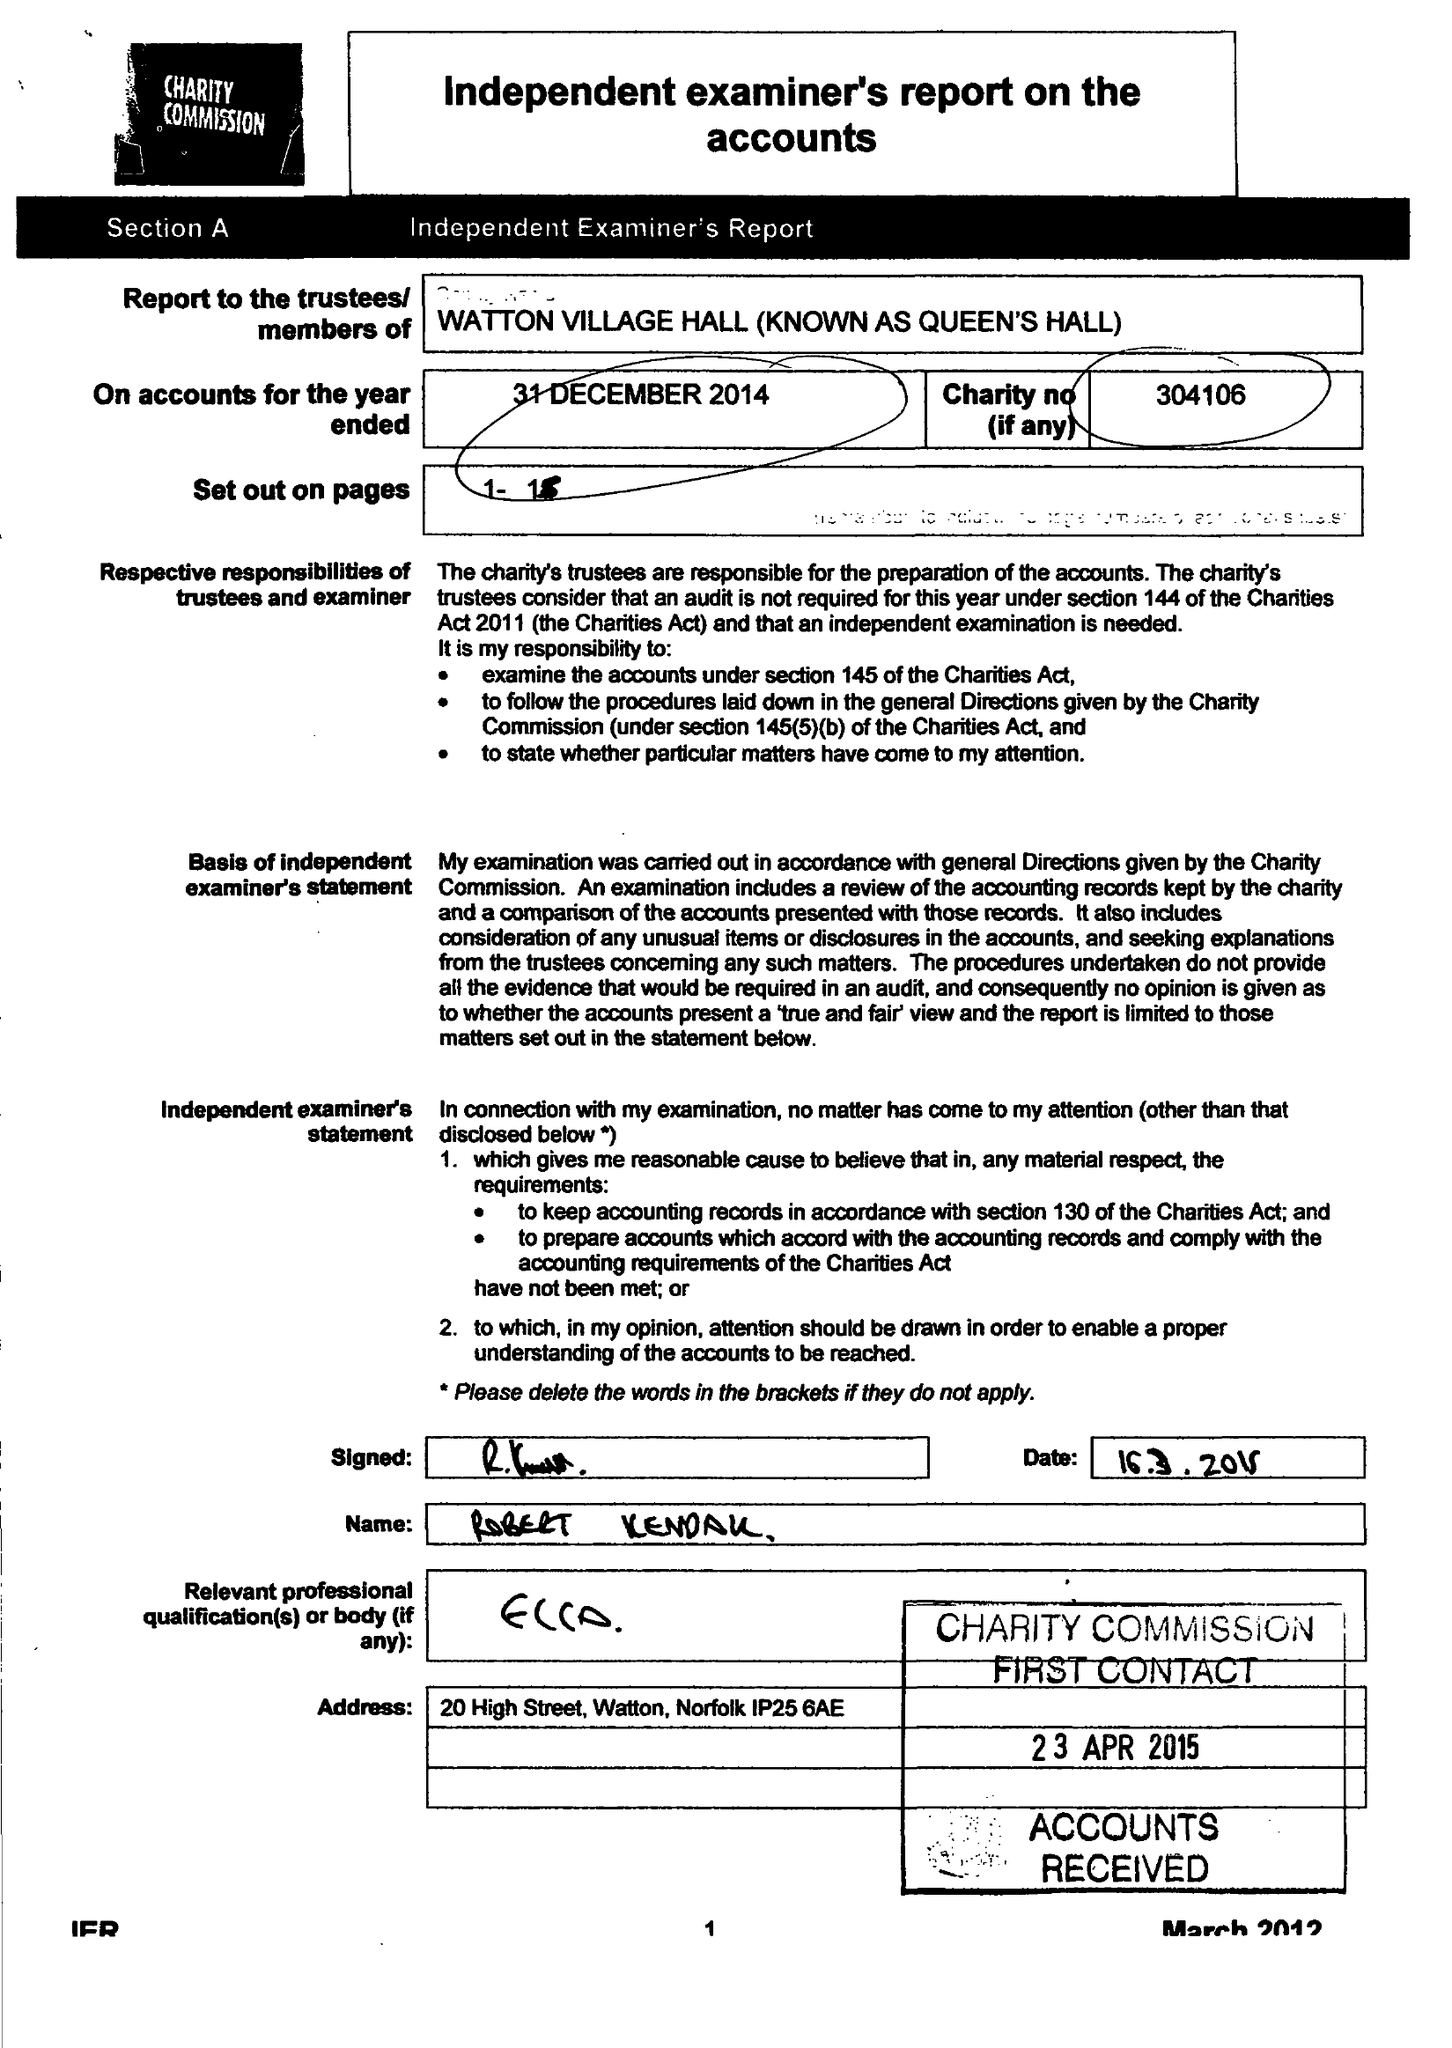What is the value for the charity_number?
Answer the question using a single word or phrase. 304106 